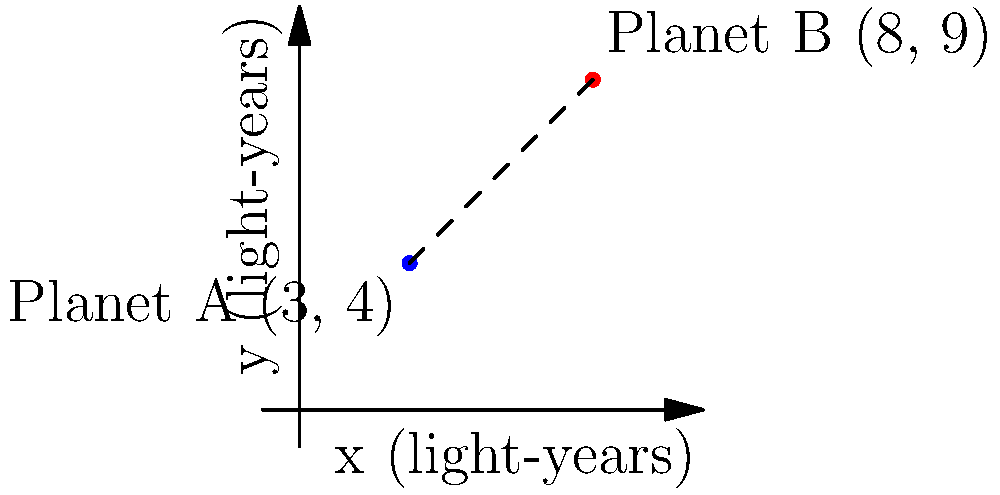In the vast expanse of the Andromeda Galaxy, two planets of interest have been discovered. Planet A has galactic coordinates (3, 4) and Planet B has galactic coordinates (8, 9), where the coordinates are measured in light-years. Calculate the distance between these two planets using the distance formula derived from the Pythagorean theorem. To find the distance between two points in a coordinate system, we can use the distance formula:

$$d = \sqrt{(x_2 - x_1)^2 + (y_2 - y_1)^2}$$

Where $(x_1, y_1)$ are the coordinates of the first point and $(x_2, y_2)$ are the coordinates of the second point.

Let's plug in our values:
* Planet A: $(x_1, y_1) = (3, 4)$
* Planet B: $(x_2, y_2) = (8, 9)$

Now, let's calculate:

1) First, find the differences:
   $x_2 - x_1 = 8 - 3 = 5$
   $y_2 - y_1 = 9 - 4 = 5$

2) Square these differences:
   $(x_2 - x_1)^2 = 5^2 = 25$
   $(y_2 - y_1)^2 = 5^2 = 25$

3) Add the squared differences:
   $25 + 25 = 50$

4) Take the square root of the sum:
   $\sqrt{50} = 5\sqrt{2} \approx 7.07$ light-years

Therefore, the distance between Planet A and Planet B is $5\sqrt{2}$ light-years, or approximately 7.07 light-years.
Answer: $5\sqrt{2}$ light-years 